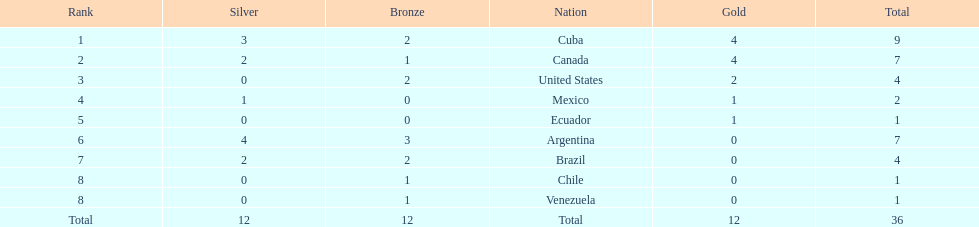Who had more silver medals, cuba or brazil? Cuba. 